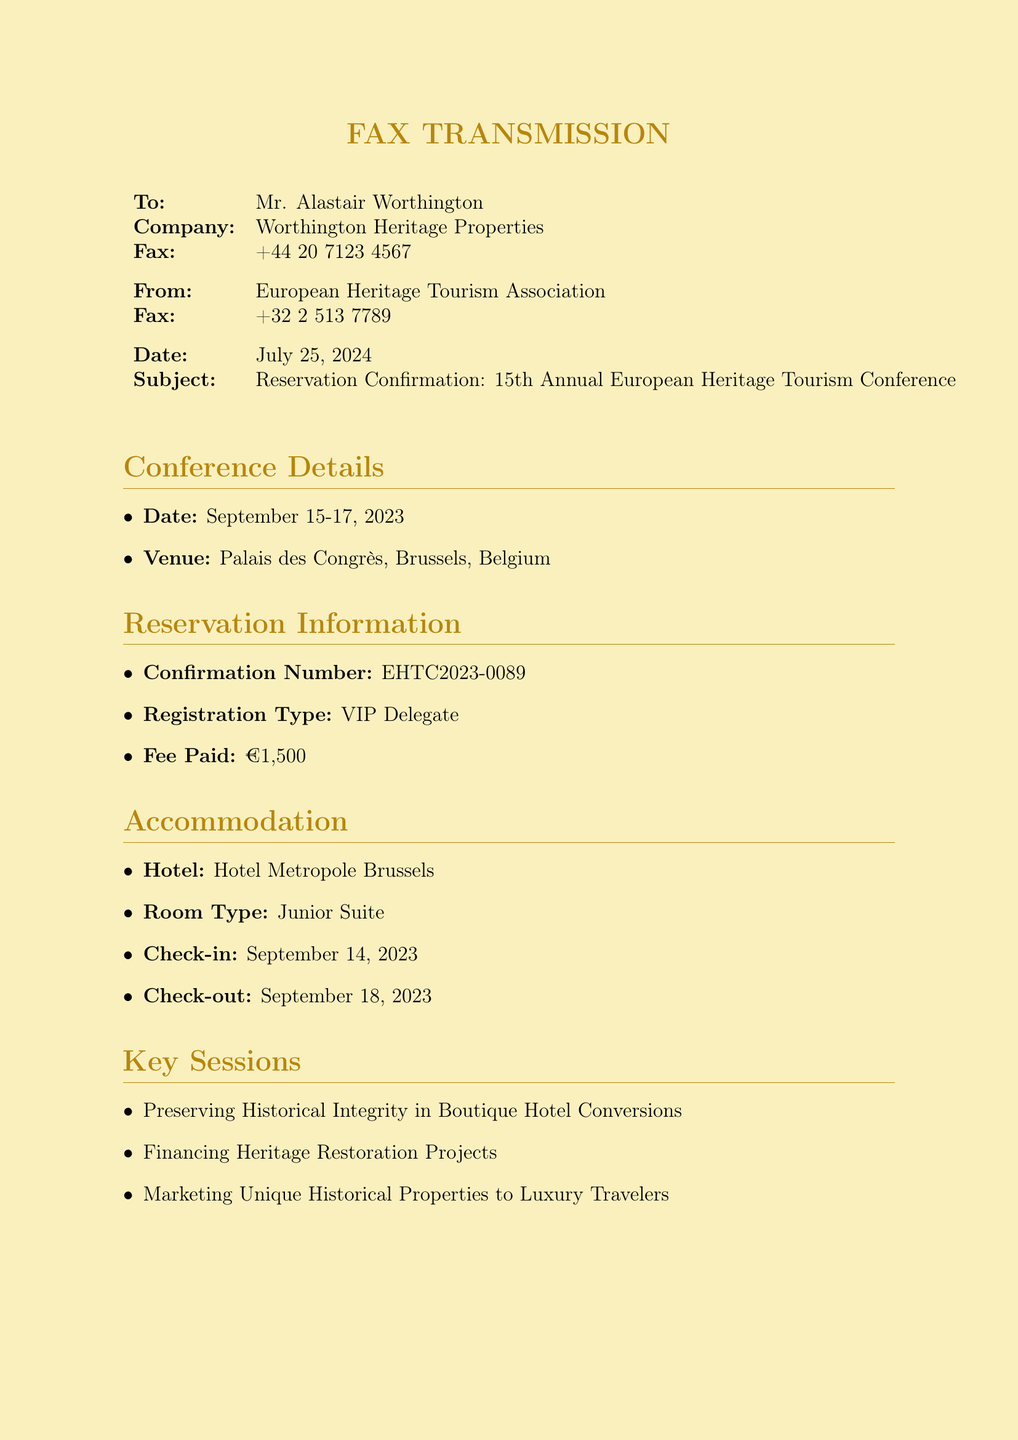What is the conference date? The conference is scheduled to take place from September 15 to September 17, 2023.
Answer: September 15-17, 2023 What is the venue of the conference? The venue for the conference is mentioned as Palais des Congrès, Brussels, Belgium.
Answer: Palais des Congrès, Brussels, Belgium What is the confirmation number? The confirmation number is provided for the reservation as EHTC2023-0089.
Answer: EHTC2023-0089 What type of accommodation is reserved? The document specifies that a Junior Suite is reserved for accommodation.
Answer: Junior Suite When is the check-in date? The check-in date for the hotel accommodation is stated as September 14, 2023.
Answer: September 14, 2023 What is the registration fee paid? The registration fee mentioned in the document is €1,500.
Answer: €1,500 Which session focuses on hotel conversions? The session titled "Preserving Historical Integrity in Boutique Hotel Conversions" is focused on hotel conversions.
Answer: Preserving Historical Integrity in Boutique Hotel Conversions What is the dress code for the networking event? The dress code specified for the gala dinner event is Black Tie.
Answer: Black Tie Who is the contact person for the conference? The contact person listed in the document is Isabelle Dupont.
Answer: Isabelle Dupont 